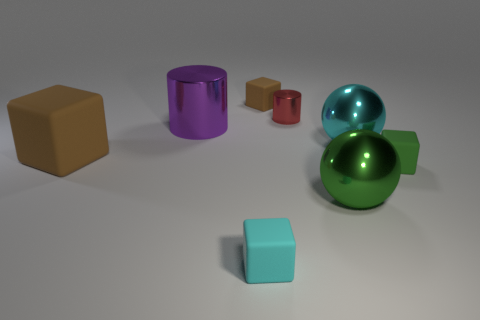Do the tiny shiny thing and the large cyan thing have the same shape?
Make the answer very short. No. Are there any small green metallic objects that have the same shape as the purple metal thing?
Provide a short and direct response. No. There is a shiny object that is behind the big shiny cylinder that is right of the big matte thing; what shape is it?
Your response must be concise. Cylinder. There is a big metallic ball to the left of the big cyan object; what is its color?
Provide a succinct answer. Green. There is a red thing that is the same material as the cyan sphere; what is its size?
Make the answer very short. Small. What size is the other brown thing that is the same shape as the large matte object?
Ensure brevity in your answer.  Small. Are any large cyan matte objects visible?
Make the answer very short. No. How many objects are matte blocks that are left of the small metal cylinder or cyan blocks?
Give a very brief answer. 3. There is a brown object that is the same size as the cyan cube; what material is it?
Ensure brevity in your answer.  Rubber. What is the color of the tiny thing that is left of the brown cube that is behind the big brown rubber block?
Provide a short and direct response. Cyan. 